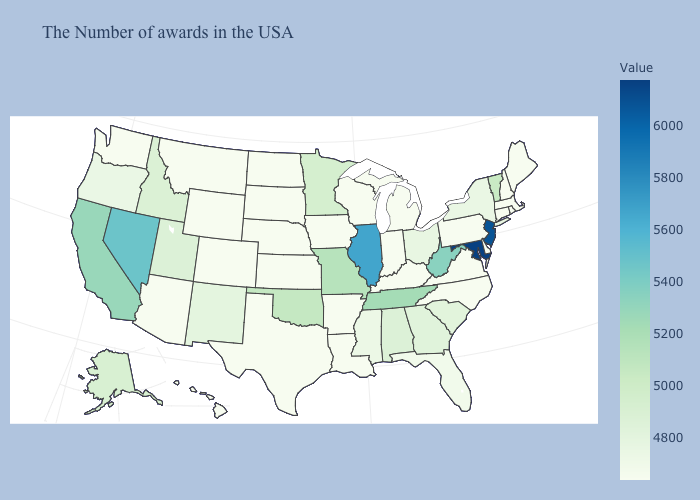Does Washington have the lowest value in the West?
Be succinct. Yes. Does Indiana have the lowest value in the USA?
Concise answer only. Yes. Does Rhode Island have a lower value than Vermont?
Quick response, please. Yes. Which states have the lowest value in the USA?
Concise answer only. Maine, Massachusetts, Rhode Island, New Hampshire, Connecticut, Delaware, Pennsylvania, Virginia, North Carolina, Michigan, Kentucky, Indiana, Wisconsin, Louisiana, Arkansas, Iowa, Kansas, Nebraska, Texas, South Dakota, North Dakota, Wyoming, Colorado, Montana, Arizona, Washington, Hawaii. Among the states that border Colorado , which have the highest value?
Write a very short answer. Oklahoma. Among the states that border Minnesota , which have the lowest value?
Quick response, please. Wisconsin, Iowa, South Dakota, North Dakota. Does Ohio have the lowest value in the USA?
Short answer required. No. Which states hav the highest value in the Northeast?
Quick response, please. New Jersey. 